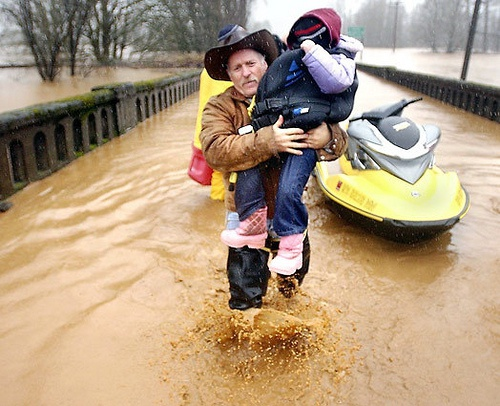Describe the objects in this image and their specific colors. I can see people in lightgray, black, lavender, navy, and gray tones, people in lightgray, black, gray, tan, and maroon tones, backpack in lightgray, black, navy, gray, and darkblue tones, and people in lightgray, khaki, orange, and tan tones in this image. 